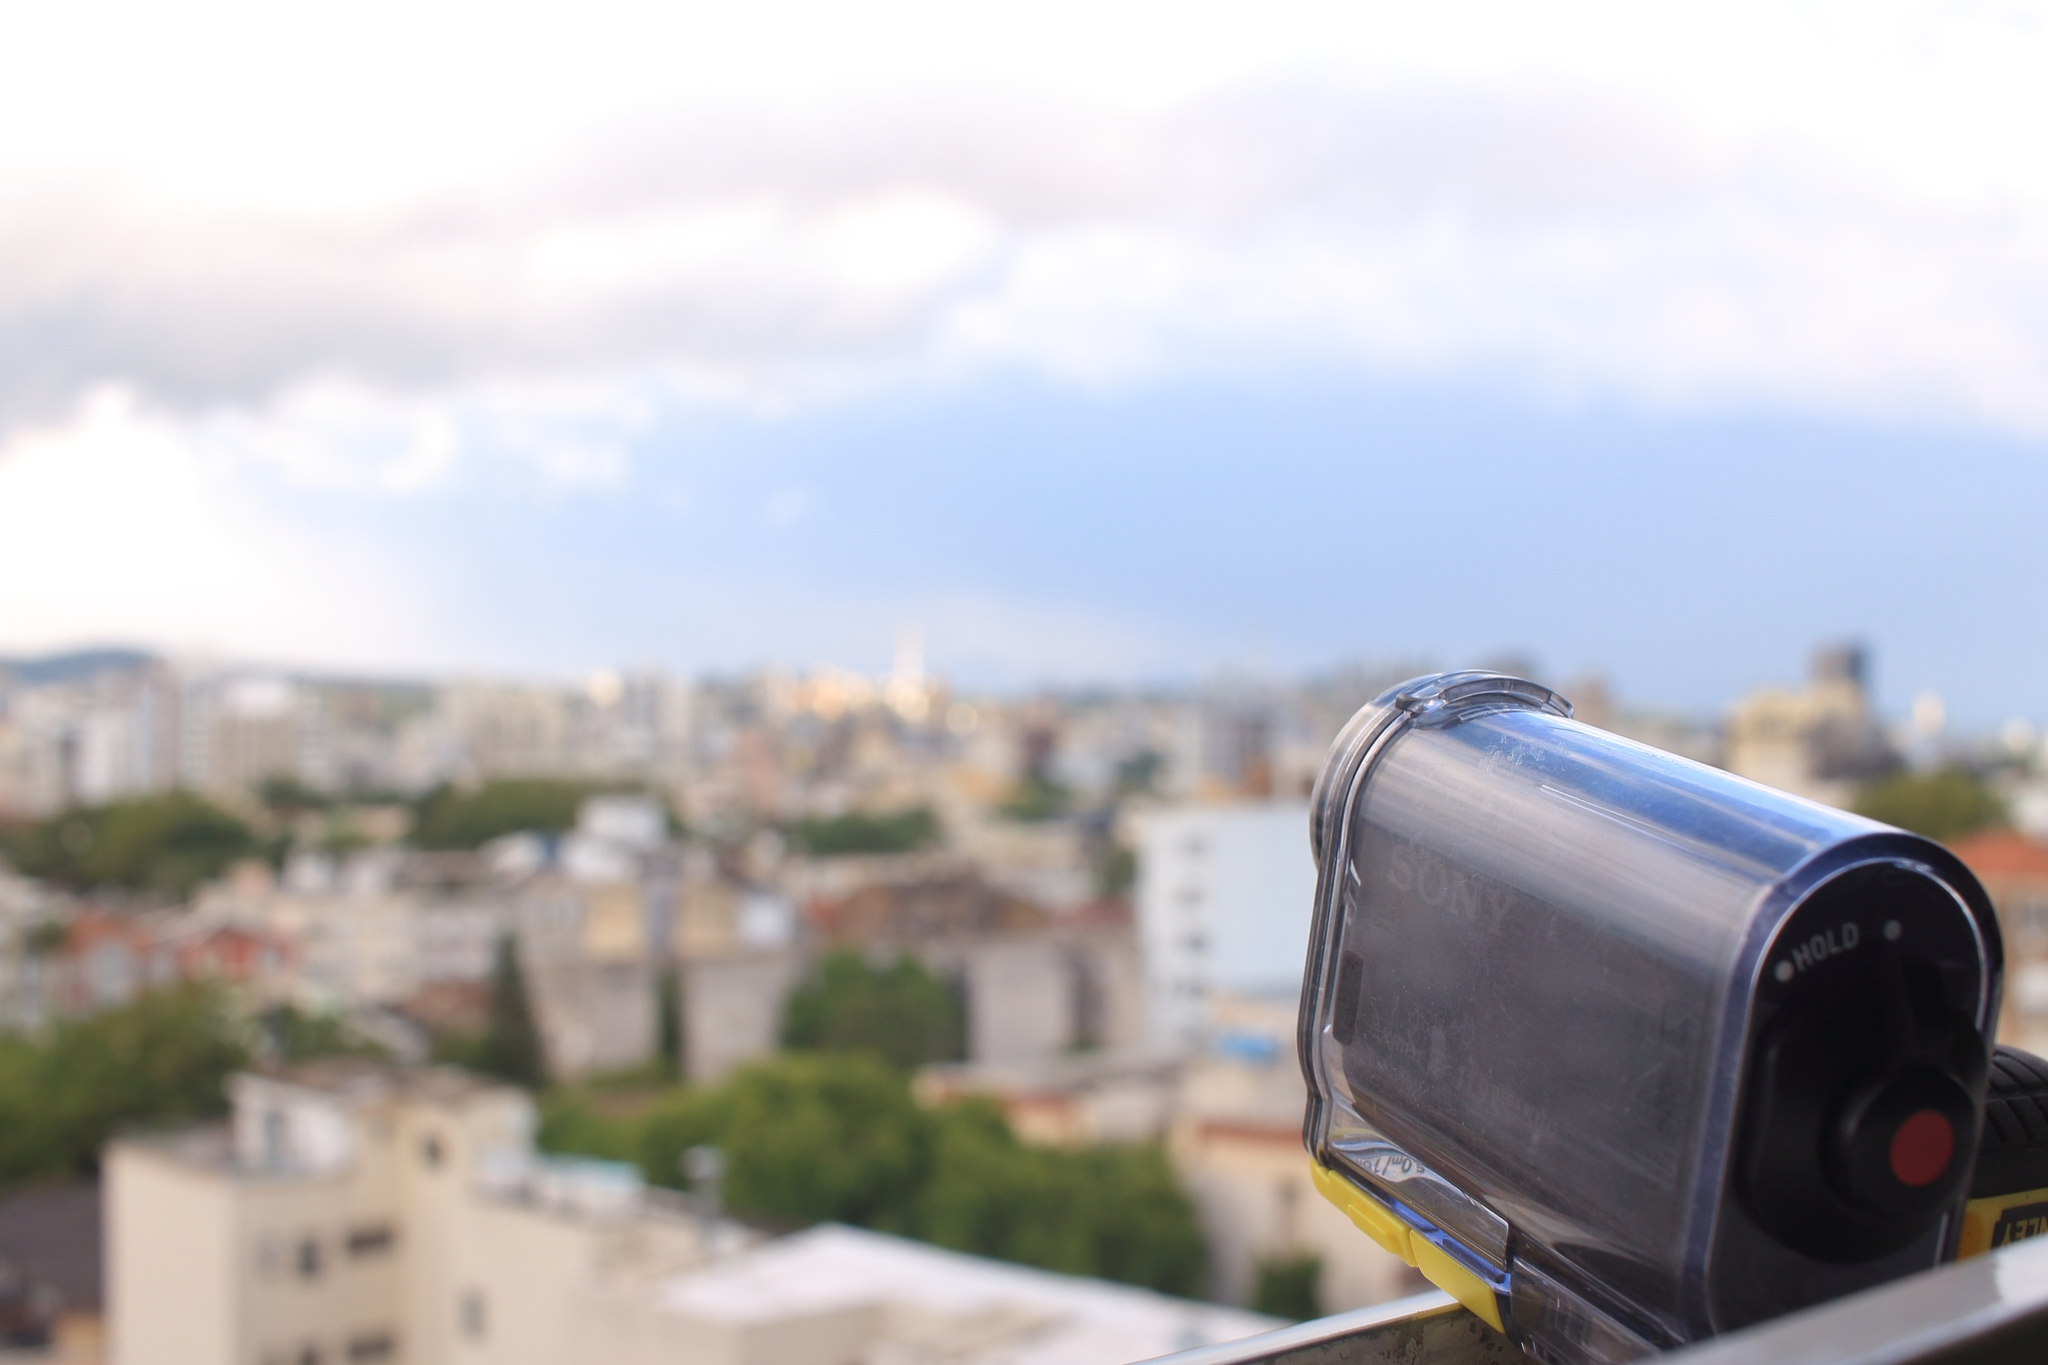Let's dive into the technology. What kind of photography equipment is being used here? The photography equipment featured in the image is a Sony camera, known for its advanced imaging capabilities and sleek design. It's perched on a sturdy black tripod, which ensures stability and precision for capturing high-quality images. This setup is ideal for professional photographers looking to capture detailed and expansive urban landscapes. What settings might the camera be using to capture this cityscape effectively? To capture the cityscape effectively, the camera might be set to a high aperture value (such as f/8 or higher) to ensure a deep depth of field, keeping both the foreground and the background in sharp focus. It could also be set to a low ISO (around 100-200) to reduce noise and maintain image clarity. Given the bright daylight, a moderate shutter speed would be suitable to avoid overexposure, while adjustments in the white balance settings would help render the true colors of the scene accurately. 